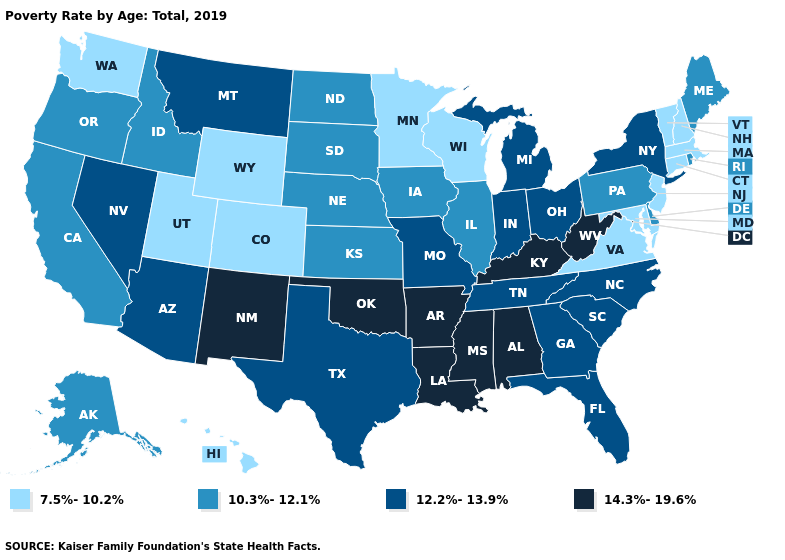What is the value of Utah?
Concise answer only. 7.5%-10.2%. Does Iowa have a higher value than New Jersey?
Keep it brief. Yes. What is the value of Massachusetts?
Quick response, please. 7.5%-10.2%. Among the states that border Rhode Island , which have the lowest value?
Short answer required. Connecticut, Massachusetts. What is the value of Montana?
Quick response, please. 12.2%-13.9%. What is the value of Connecticut?
Quick response, please. 7.5%-10.2%. What is the value of Arkansas?
Quick response, please. 14.3%-19.6%. Does South Carolina have the lowest value in the USA?
Short answer required. No. Name the states that have a value in the range 10.3%-12.1%?
Write a very short answer. Alaska, California, Delaware, Idaho, Illinois, Iowa, Kansas, Maine, Nebraska, North Dakota, Oregon, Pennsylvania, Rhode Island, South Dakota. How many symbols are there in the legend?
Keep it brief. 4. Name the states that have a value in the range 10.3%-12.1%?
Answer briefly. Alaska, California, Delaware, Idaho, Illinois, Iowa, Kansas, Maine, Nebraska, North Dakota, Oregon, Pennsylvania, Rhode Island, South Dakota. What is the value of New Jersey?
Quick response, please. 7.5%-10.2%. What is the highest value in the MidWest ?
Answer briefly. 12.2%-13.9%. Does Arkansas have the highest value in the USA?
Quick response, please. Yes. Among the states that border Minnesota , does South Dakota have the highest value?
Answer briefly. Yes. 